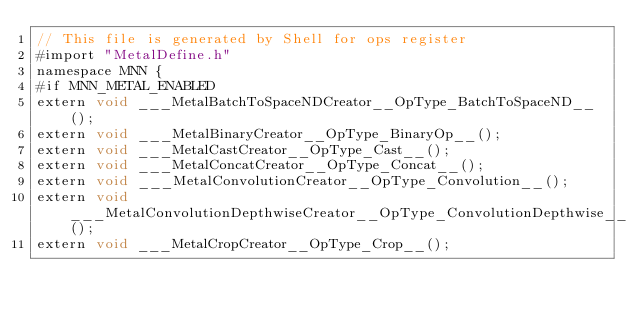<code> <loc_0><loc_0><loc_500><loc_500><_ObjectiveC_>// This file is generated by Shell for ops register
#import "MetalDefine.h"
namespace MNN {
#if MNN_METAL_ENABLED
extern void ___MetalBatchToSpaceNDCreator__OpType_BatchToSpaceND__();
extern void ___MetalBinaryCreator__OpType_BinaryOp__();
extern void ___MetalCastCreator__OpType_Cast__();
extern void ___MetalConcatCreator__OpType_Concat__();
extern void ___MetalConvolutionCreator__OpType_Convolution__();
extern void ___MetalConvolutionDepthwiseCreator__OpType_ConvolutionDepthwise__();
extern void ___MetalCropCreator__OpType_Crop__();</code> 